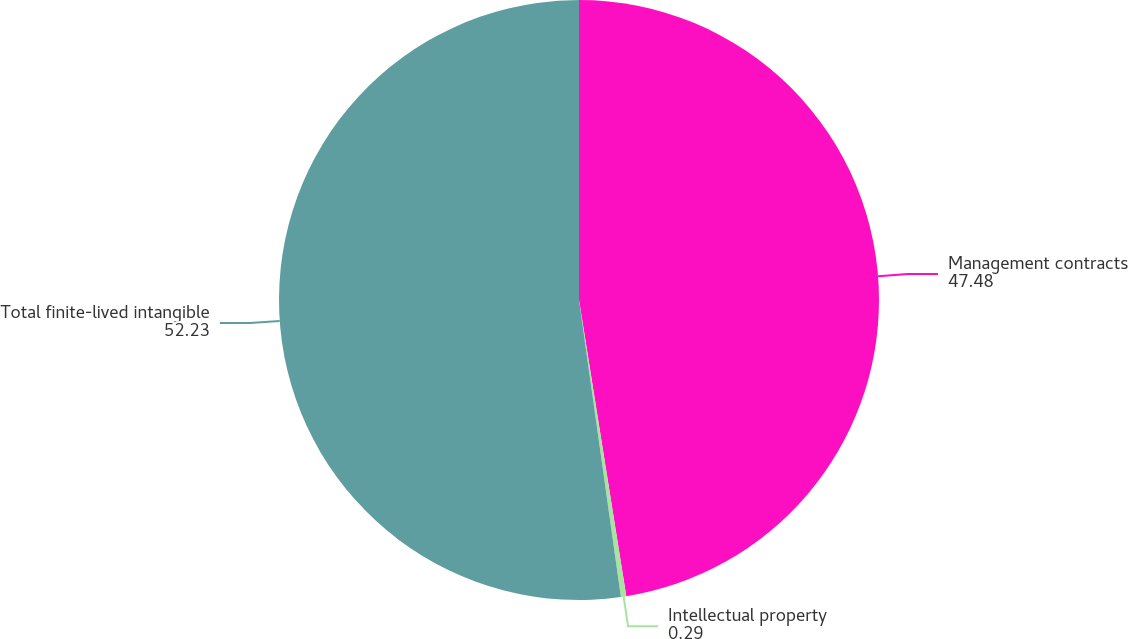Convert chart. <chart><loc_0><loc_0><loc_500><loc_500><pie_chart><fcel>Management contracts<fcel>Intellectual property<fcel>Total finite-lived intangible<nl><fcel>47.48%<fcel>0.29%<fcel>52.23%<nl></chart> 